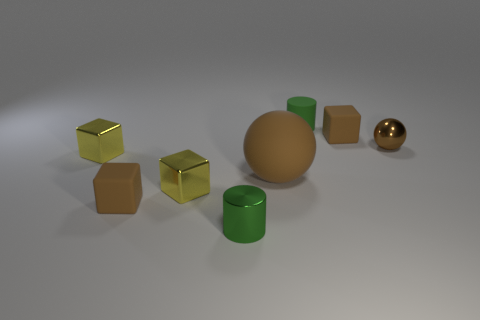What shape is the green thing behind the tiny brown metal sphere?
Offer a very short reply. Cylinder. How many things are tiny green rubber cylinders or blocks?
Provide a succinct answer. 5. Is the size of the rubber cylinder the same as the ball that is to the right of the big brown matte ball?
Provide a short and direct response. Yes. What number of other things are made of the same material as the large brown thing?
Provide a short and direct response. 3. How many things are small green things that are on the left side of the large brown ball or tiny green cylinders that are on the left side of the tiny green matte cylinder?
Provide a short and direct response. 1. What is the material of the small brown thing that is the same shape as the large brown matte object?
Give a very brief answer. Metal. Are there any small yellow metallic things?
Give a very brief answer. Yes. What is the size of the metallic object that is both in front of the large brown rubber sphere and on the left side of the small green shiny cylinder?
Make the answer very short. Small. What is the shape of the tiny green rubber thing?
Offer a very short reply. Cylinder. Are there any yellow shiny objects that are on the left side of the small brown rubber block on the left side of the tiny matte cylinder?
Make the answer very short. Yes. 